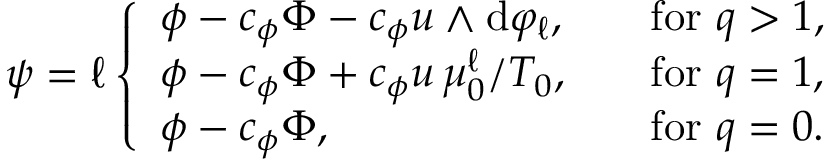<formula> <loc_0><loc_0><loc_500><loc_500>\psi = \ell \left \{ \begin{array} { l l } { \phi - c _ { \phi } \Phi - c _ { \phi } u \wedge d \varphi _ { \ell } , } & { \quad f o r q > 1 , } \\ { \phi - c _ { \phi } \Phi + c _ { \phi } u \, \mu _ { 0 } ^ { \ell } / T _ { 0 } , } & { \quad f o r q = 1 , } \\ { \phi - c _ { \phi } \Phi , } & { \quad f o r q = 0 . } \end{array}</formula> 